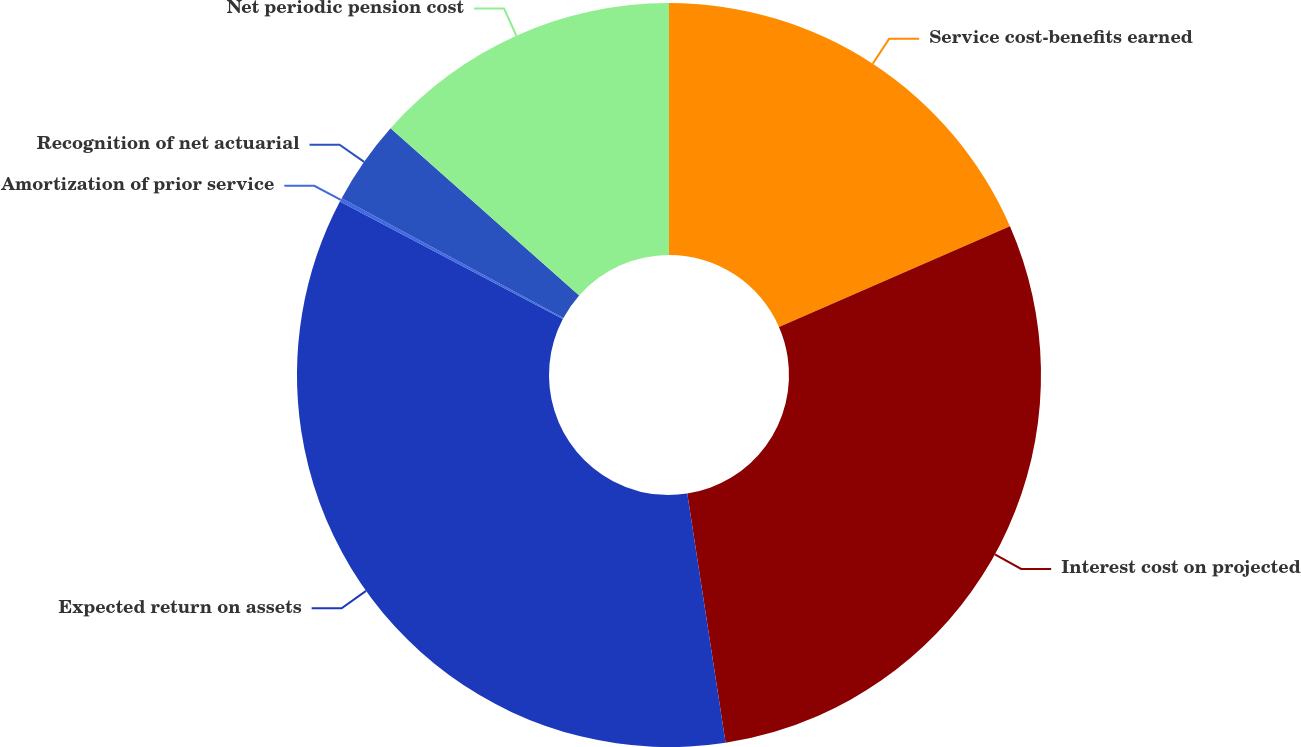Convert chart to OTSL. <chart><loc_0><loc_0><loc_500><loc_500><pie_chart><fcel>Service cost-benefits earned<fcel>Interest cost on projected<fcel>Expected return on assets<fcel>Amortization of prior service<fcel>Recognition of net actuarial<fcel>Net periodic pension cost<nl><fcel>18.45%<fcel>29.12%<fcel>35.15%<fcel>0.16%<fcel>3.66%<fcel>13.46%<nl></chart> 